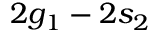Convert formula to latex. <formula><loc_0><loc_0><loc_500><loc_500>2 g _ { 1 } - 2 s _ { 2 }</formula> 